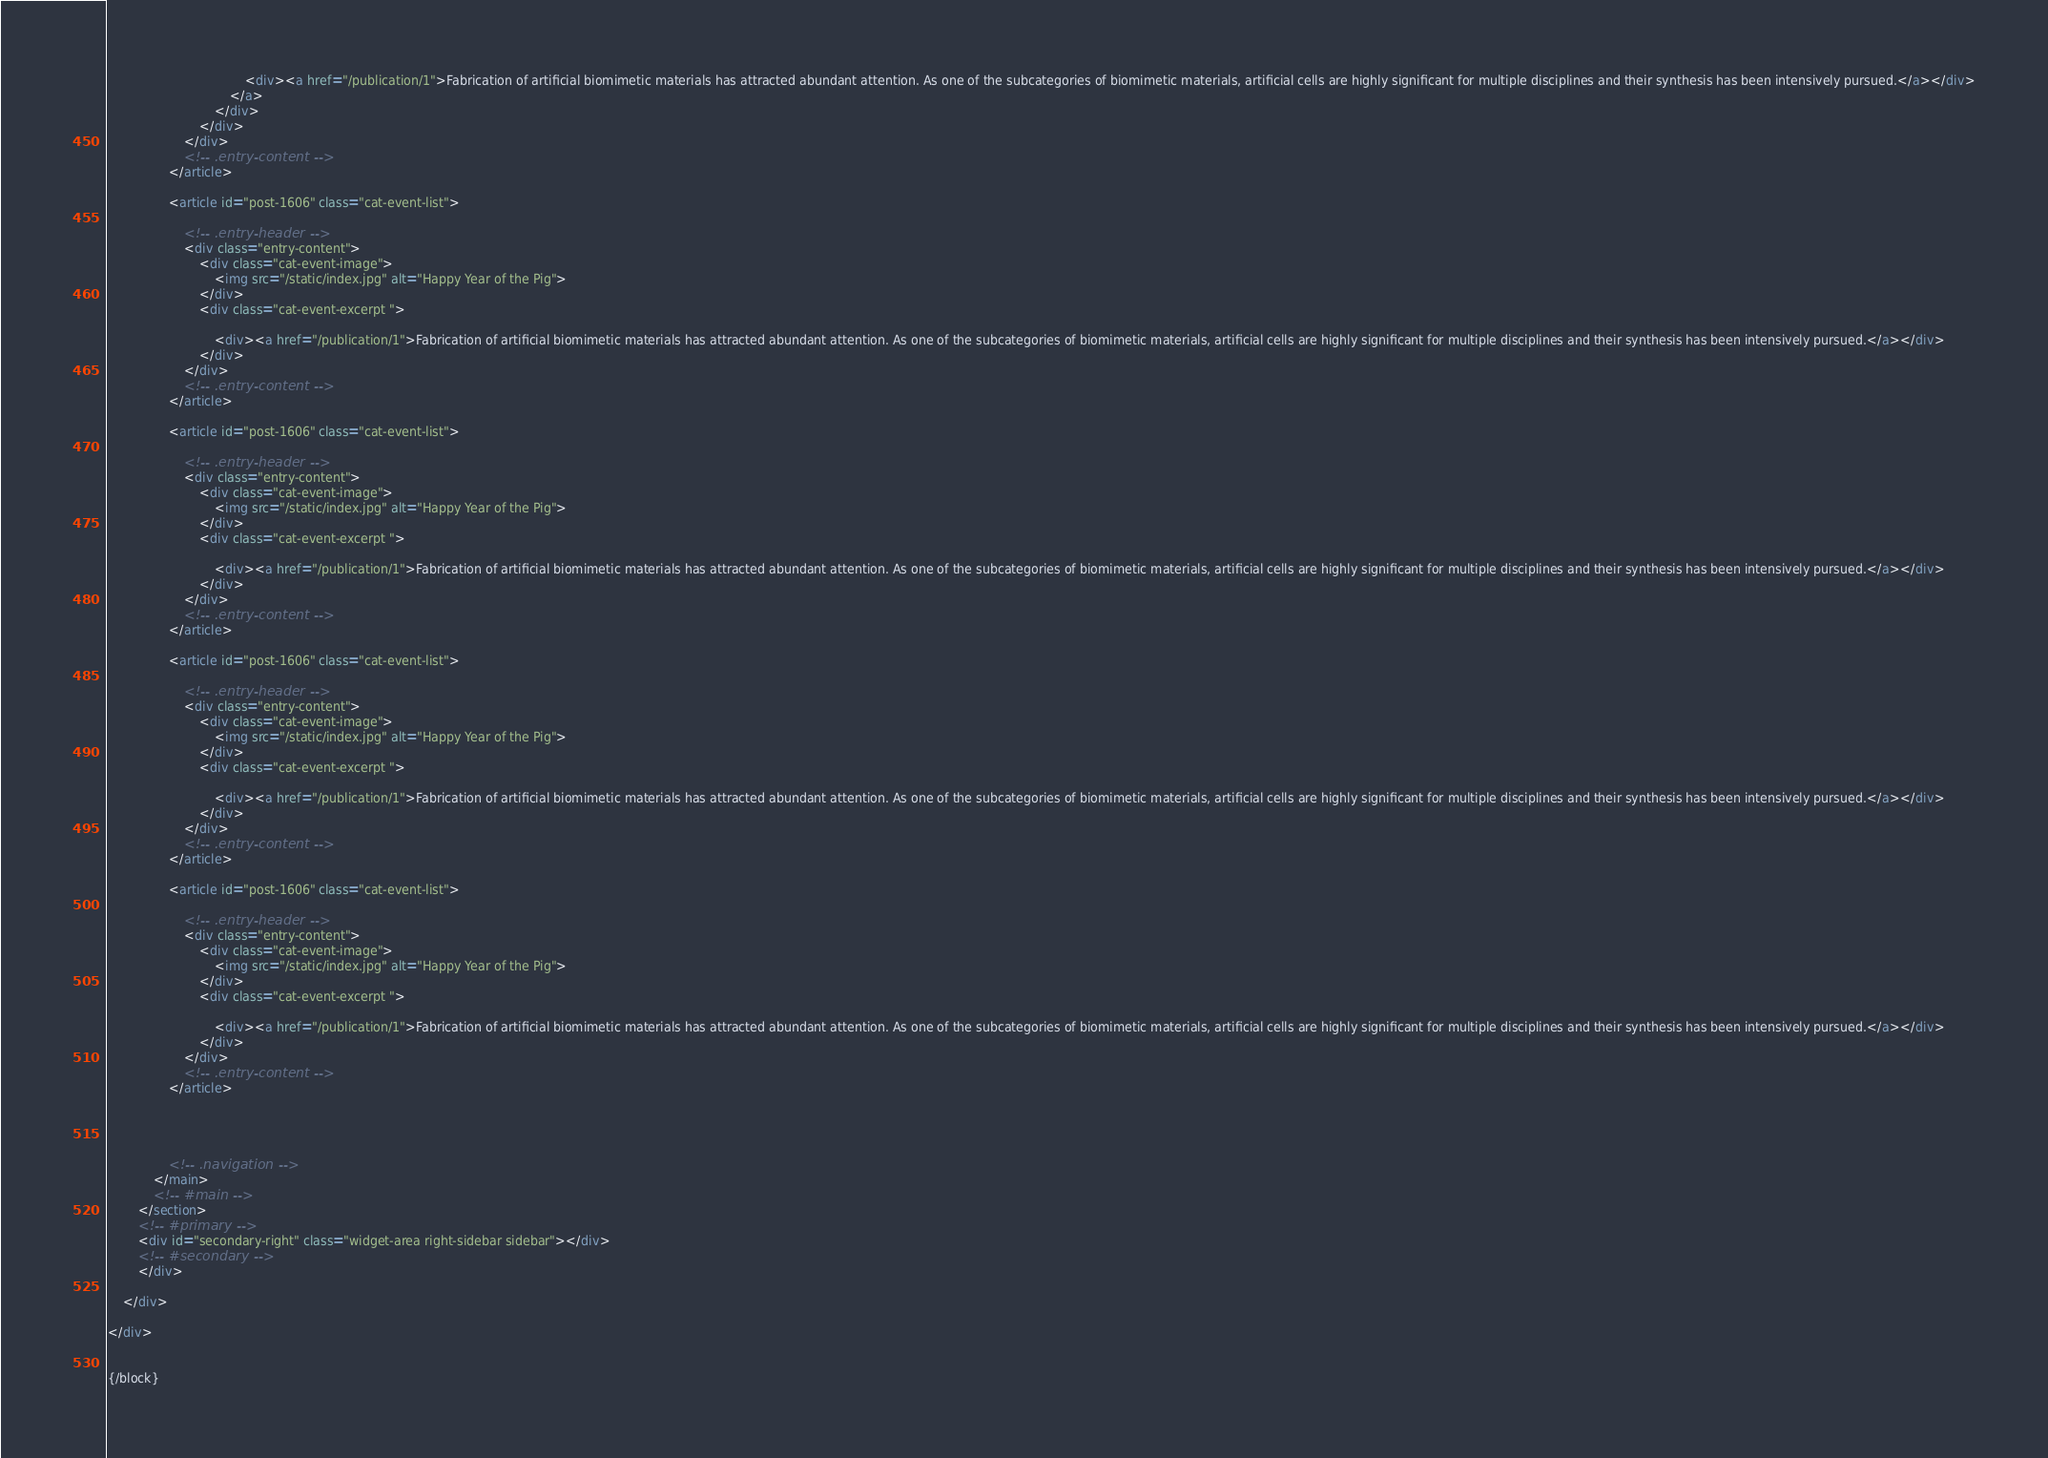Convert code to text. <code><loc_0><loc_0><loc_500><loc_500><_HTML_>                                    <div><a href="/publication/1">Fabrication of artificial biomimetic materials has attracted abundant attention. As one of the subcategories of biomimetic materials, artificial cells are highly significant for multiple disciplines and their synthesis has been intensively pursued.</a></div>
                                </a>
                            </div>
                        </div>
                    </div>
                    <!-- .entry-content -->
                </article>

                <article id="post-1606" class="cat-event-list">

                    <!-- .entry-header -->
                    <div class="entry-content">
                        <div class="cat-event-image">
                            <img src="/static/index.jpg" alt="Happy Year of the Pig">
                        </div>
                        <div class="cat-event-excerpt ">

                            <div><a href="/publication/1">Fabrication of artificial biomimetic materials has attracted abundant attention. As one of the subcategories of biomimetic materials, artificial cells are highly significant for multiple disciplines and their synthesis has been intensively pursued.</a></div>
                        </div>
                    </div>
                    <!-- .entry-content -->
                </article>

                <article id="post-1606" class="cat-event-list">

                    <!-- .entry-header -->
                    <div class="entry-content">
                        <div class="cat-event-image">
                            <img src="/static/index.jpg" alt="Happy Year of the Pig">
                        </div>
                        <div class="cat-event-excerpt ">

                            <div><a href="/publication/1">Fabrication of artificial biomimetic materials has attracted abundant attention. As one of the subcategories of biomimetic materials, artificial cells are highly significant for multiple disciplines and their synthesis has been intensively pursued.</a></div>
                        </div>
                    </div>
                    <!-- .entry-content -->
                </article>

                <article id="post-1606" class="cat-event-list">

                    <!-- .entry-header -->
                    <div class="entry-content">
                        <div class="cat-event-image">
                            <img src="/static/index.jpg" alt="Happy Year of the Pig">
                        </div>
                        <div class="cat-event-excerpt ">

                            <div><a href="/publication/1">Fabrication of artificial biomimetic materials has attracted abundant attention. As one of the subcategories of biomimetic materials, artificial cells are highly significant for multiple disciplines and their synthesis has been intensively pursued.</a></div>
                        </div>
                    </div>
                    <!-- .entry-content -->
                </article>

                <article id="post-1606" class="cat-event-list">

                    <!-- .entry-header -->
                    <div class="entry-content">
                        <div class="cat-event-image">
                            <img src="/static/index.jpg" alt="Happy Year of the Pig">
                        </div>
                        <div class="cat-event-excerpt ">

                            <div><a href="/publication/1">Fabrication of artificial biomimetic materials has attracted abundant attention. As one of the subcategories of biomimetic materials, artificial cells are highly significant for multiple disciplines and their synthesis has been intensively pursued.</a></div>
                        </div>
                    </div>
                    <!-- .entry-content -->
                </article>




                <!-- .navigation -->
            </main>
            <!-- #main -->
        </section>
        <!-- #primary -->
        <div id="secondary-right" class="widget-area right-sidebar sidebar"></div>
        <!-- #secondary -->
        </div>

    </div>

</div>


{/block}</code> 